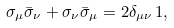Convert formula to latex. <formula><loc_0><loc_0><loc_500><loc_500>\sigma _ { \mu } \bar { \sigma } _ { \nu } + \sigma _ { \nu } \bar { \sigma } _ { \mu } = 2 \delta _ { \mu \nu } \, 1 ,</formula> 